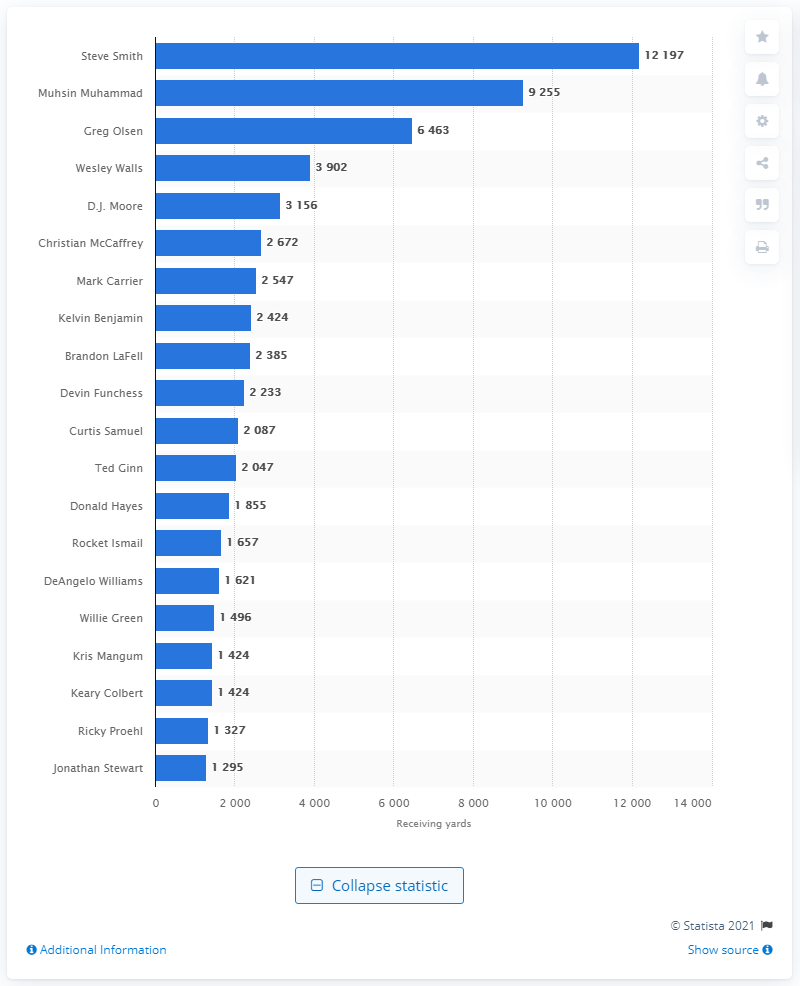Draw attention to some important aspects in this diagram. The Carolina Panthers have the most successful career receiver, who is none other than Steve Smith. 